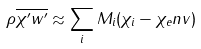<formula> <loc_0><loc_0><loc_500><loc_500>\rho \overline { \chi ^ { \prime } w ^ { \prime } } \approx \sum _ { i } M _ { i } ( \chi _ { i } - \chi _ { e } n v )</formula> 